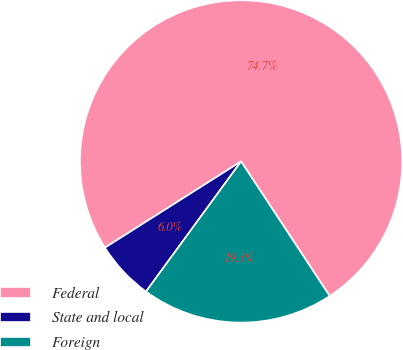<chart> <loc_0><loc_0><loc_500><loc_500><pie_chart><fcel>Federal<fcel>State and local<fcel>Foreign<nl><fcel>74.73%<fcel>5.97%<fcel>19.31%<nl></chart> 